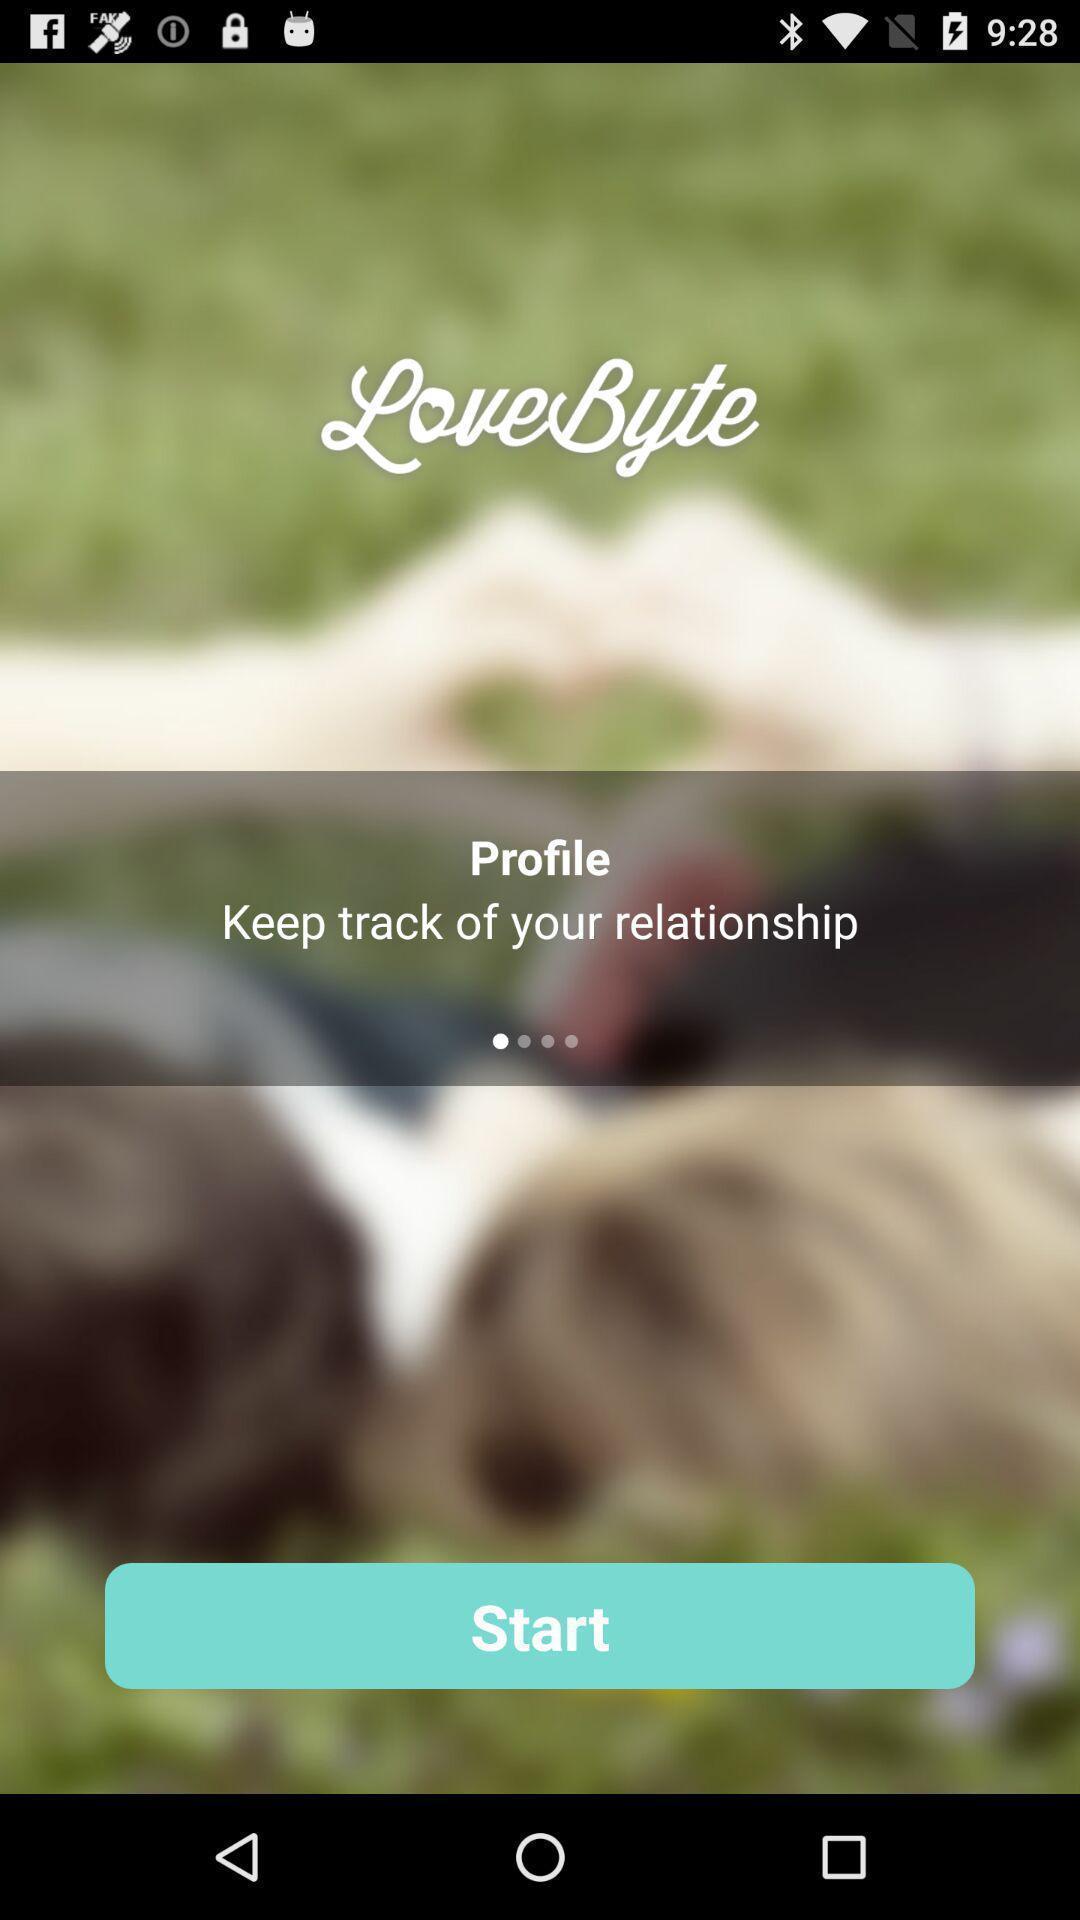Describe this image in words. Welcome page for a relationship tracking app. 